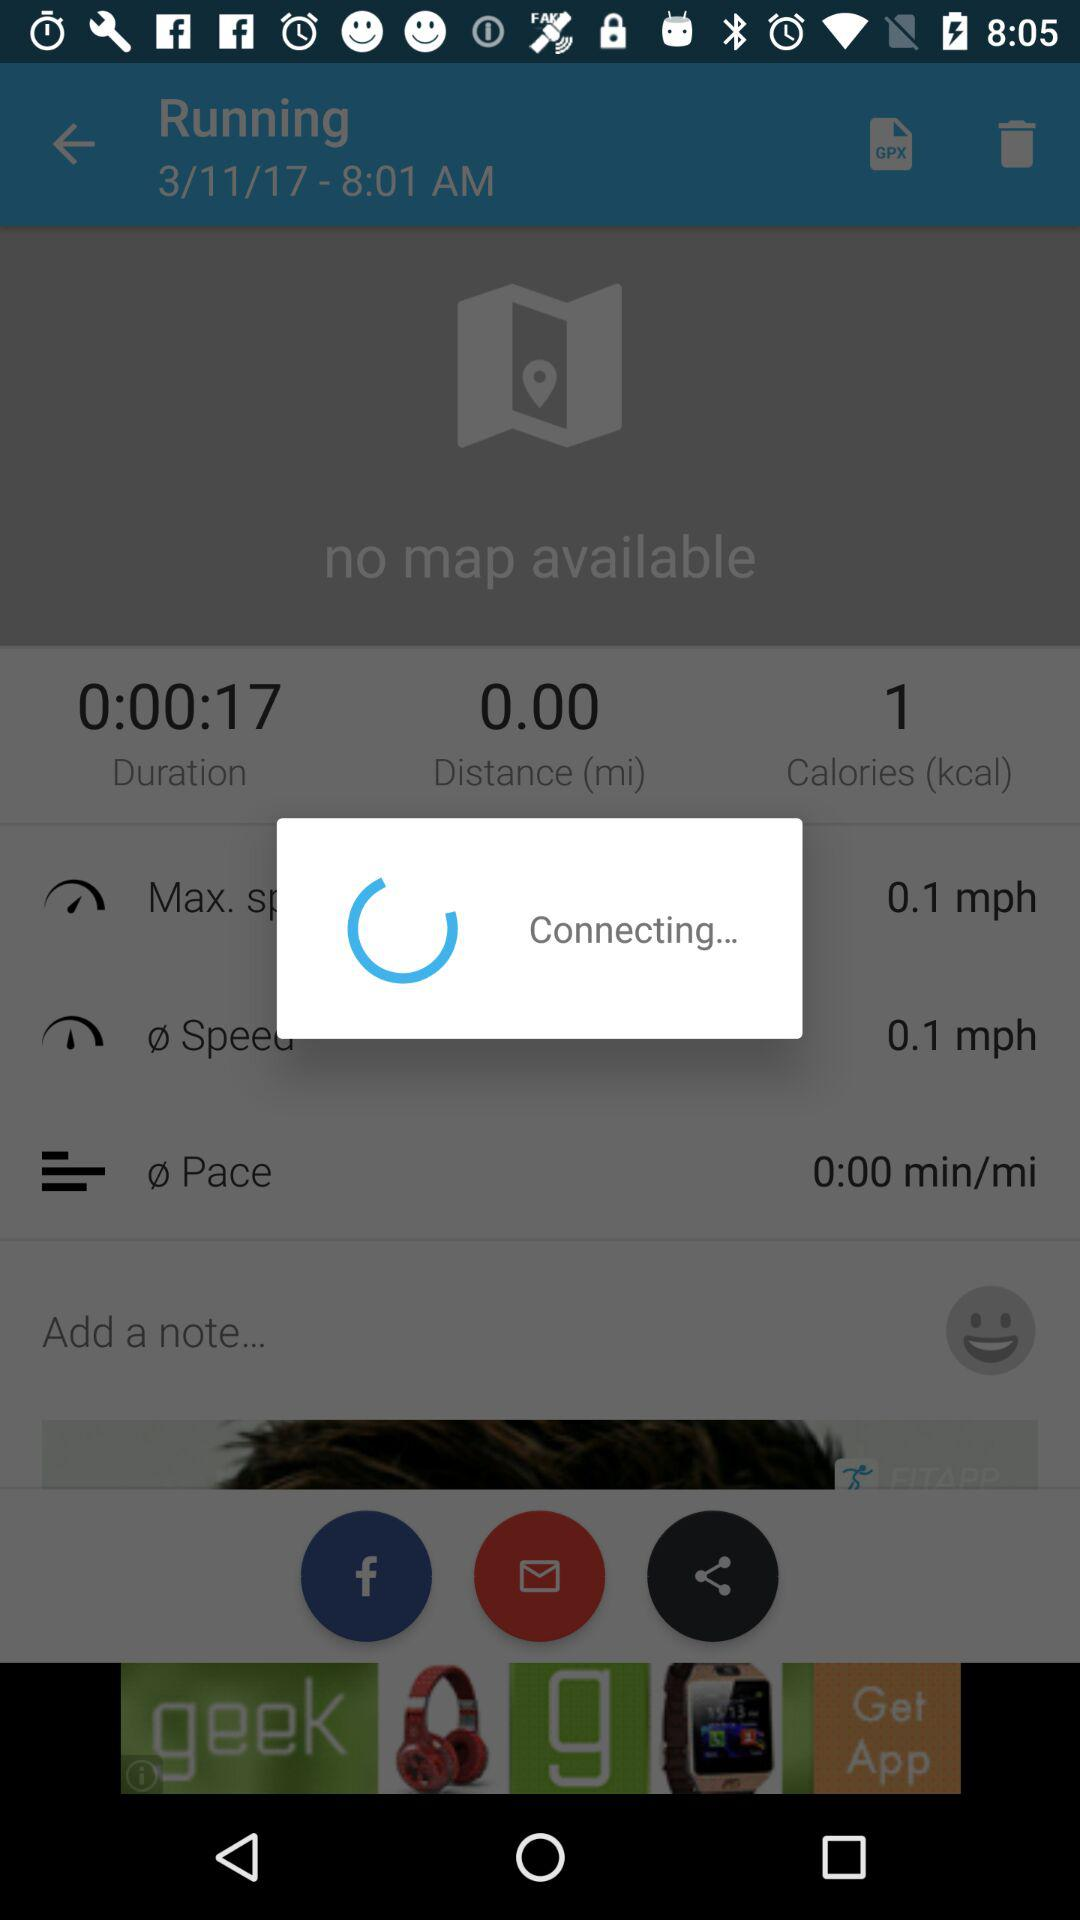What is the pace? The pace is 0:00. 